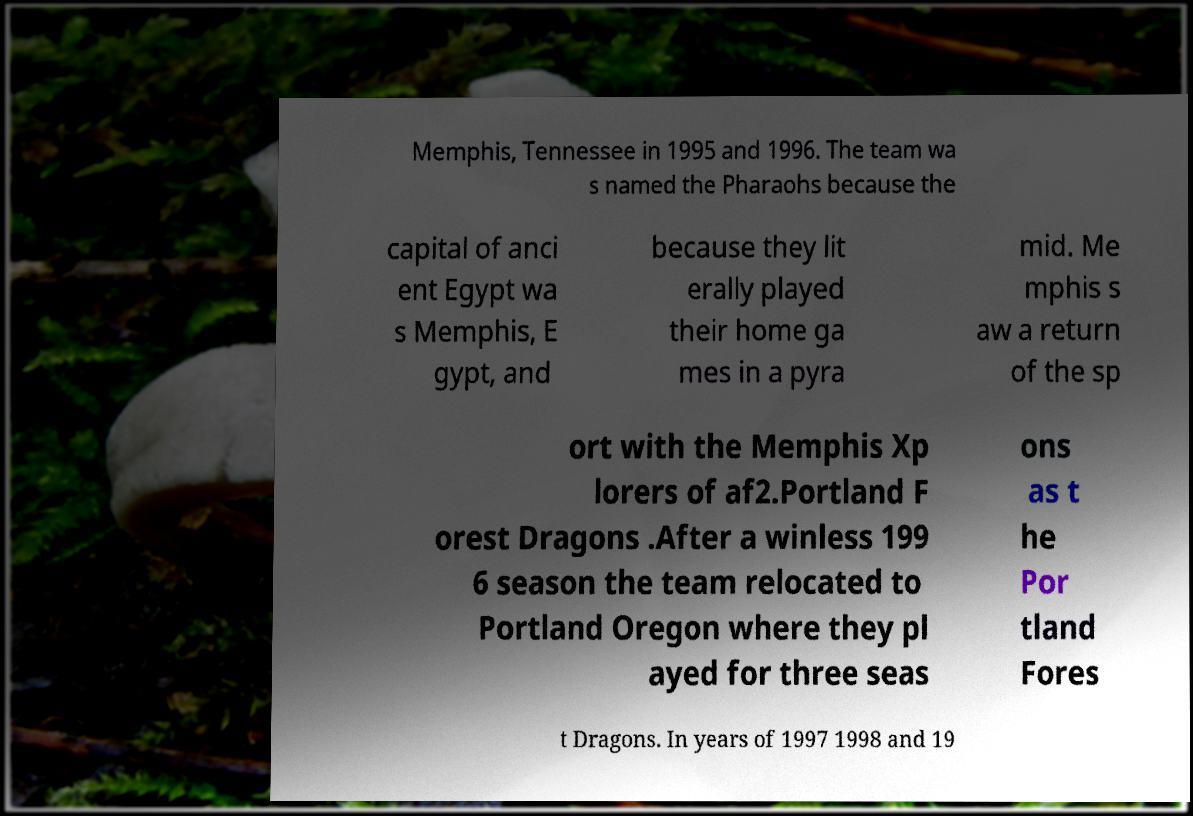Could you assist in decoding the text presented in this image and type it out clearly? Memphis, Tennessee in 1995 and 1996. The team wa s named the Pharaohs because the capital of anci ent Egypt wa s Memphis, E gypt, and because they lit erally played their home ga mes in a pyra mid. Me mphis s aw a return of the sp ort with the Memphis Xp lorers of af2.Portland F orest Dragons .After a winless 199 6 season the team relocated to Portland Oregon where they pl ayed for three seas ons as t he Por tland Fores t Dragons. In years of 1997 1998 and 19 